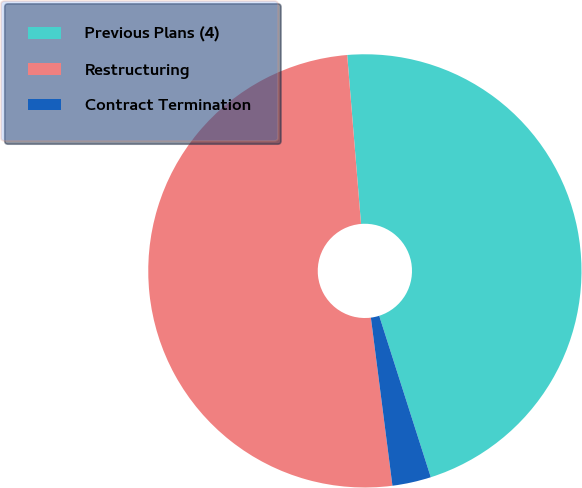<chart> <loc_0><loc_0><loc_500><loc_500><pie_chart><fcel>Previous Plans (4)<fcel>Restructuring<fcel>Contract Termination<nl><fcel>46.38%<fcel>50.73%<fcel>2.89%<nl></chart> 